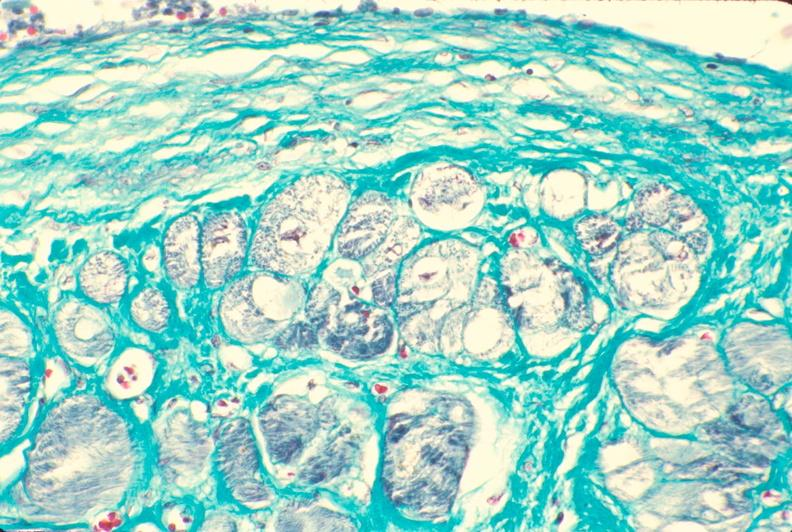where is this in?
Answer the question using a single word or phrase. In heart 